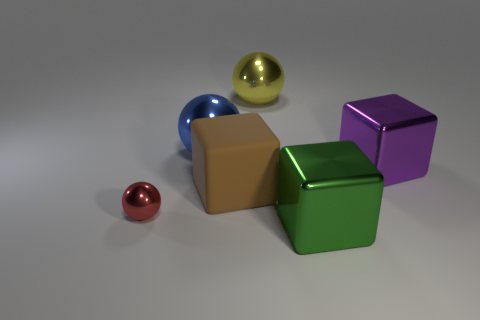Add 1 big metallic objects. How many objects exist? 7 Subtract all tiny red metal things. Subtract all tiny red shiny balls. How many objects are left? 4 Add 5 purple blocks. How many purple blocks are left? 6 Add 2 large cyan matte cylinders. How many large cyan matte cylinders exist? 2 Subtract 0 blue cylinders. How many objects are left? 6 